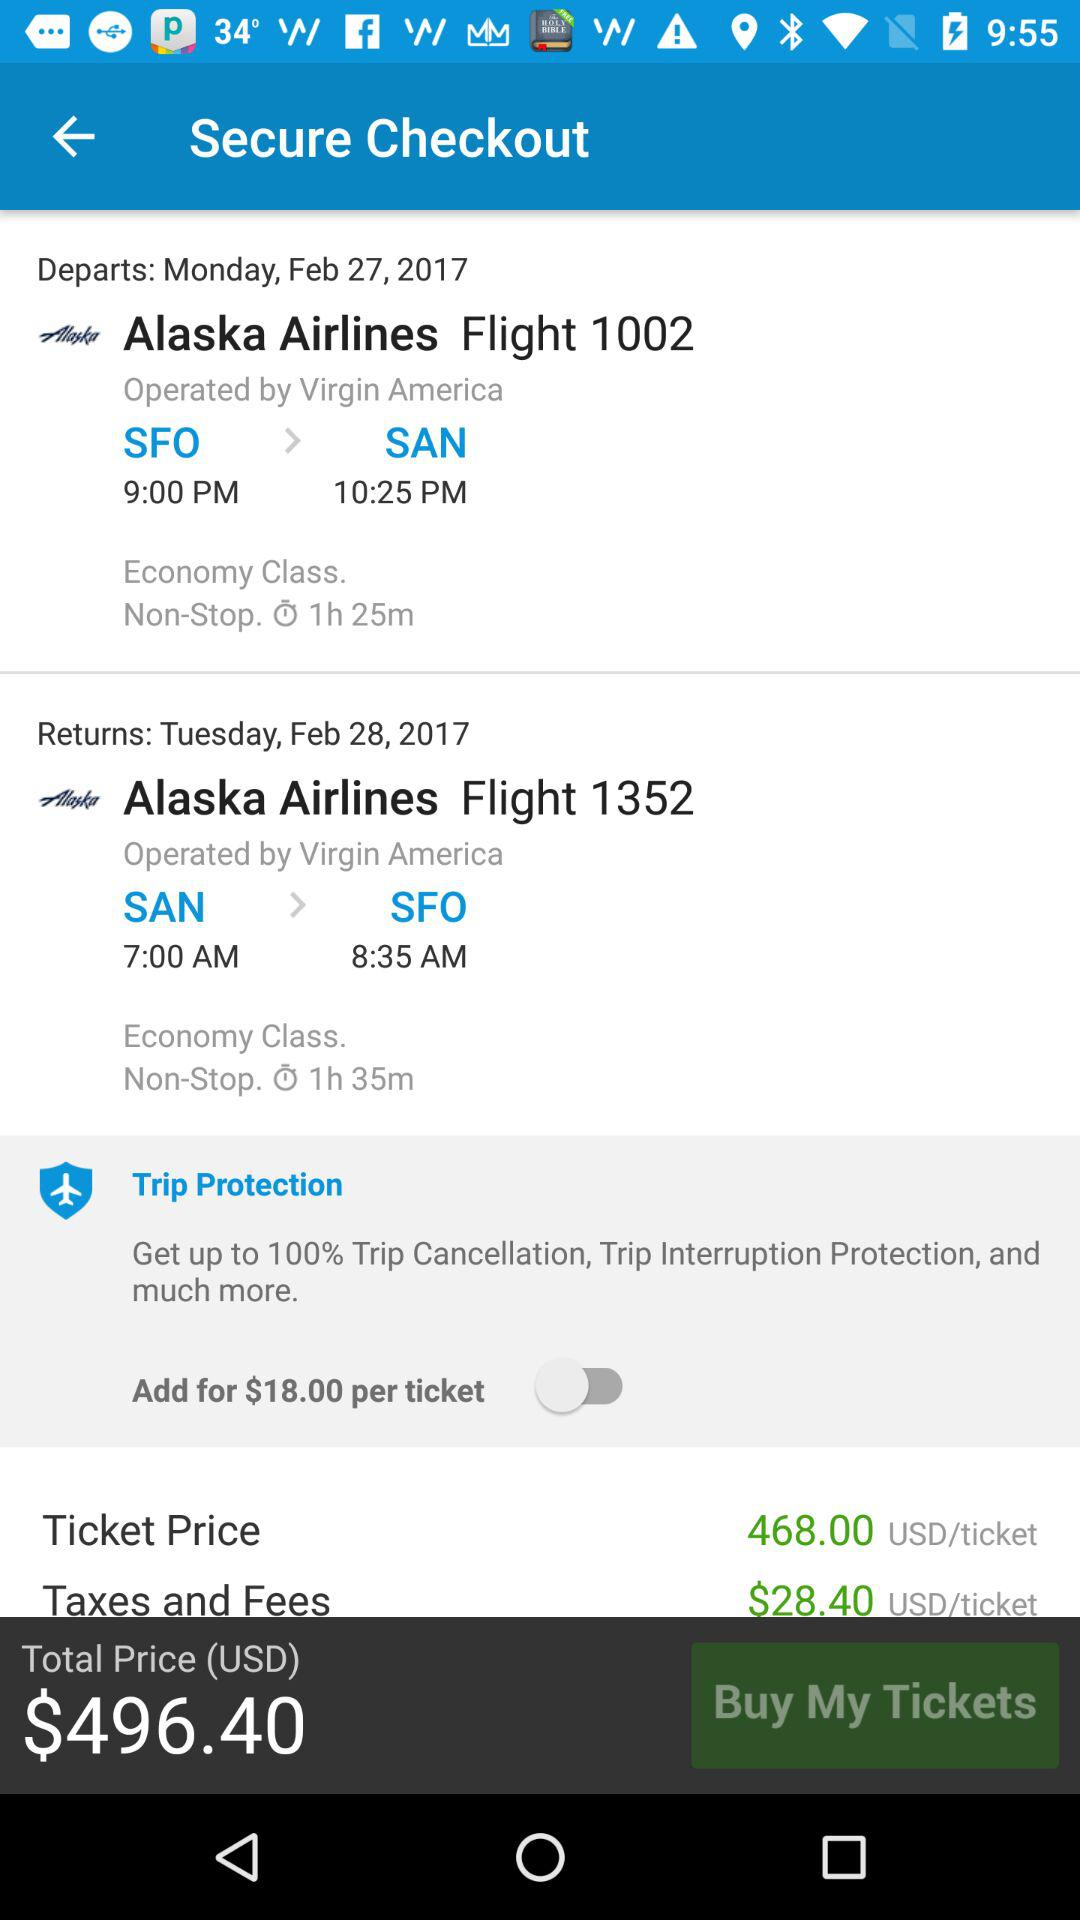From where to where is the flight?
When the provided information is insufficient, respond with <no answer>. <no answer> 